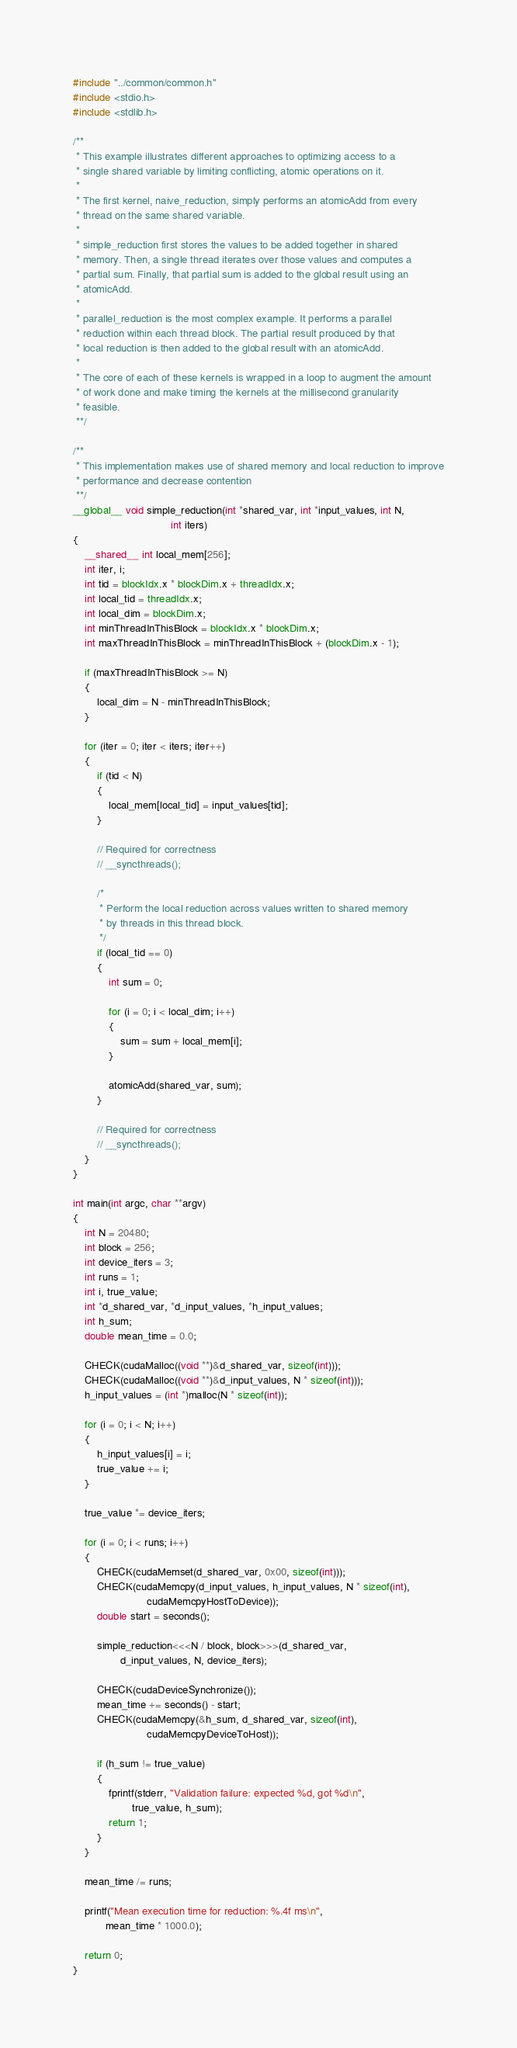<code> <loc_0><loc_0><loc_500><loc_500><_Cuda_>#include "../common/common.h"
#include <stdio.h>
#include <stdlib.h>

/**
 * This example illustrates different approaches to optimizing access to a
 * single shared variable by limiting conflicting, atomic operations on it.
 *
 * The first kernel, naive_reduction, simply performs an atomicAdd from every
 * thread on the same shared variable.
 *
 * simple_reduction first stores the values to be added together in shared
 * memory. Then, a single thread iterates over those values and computes a
 * partial sum. Finally, that partial sum is added to the global result using an
 * atomicAdd.
 *
 * parallel_reduction is the most complex example. It performs a parallel
 * reduction within each thread block. The partial result produced by that
 * local reduction is then added to the global result with an atomicAdd.
 *
 * The core of each of these kernels is wrapped in a loop to augment the amount
 * of work done and make timing the kernels at the millisecond granularity
 * feasible.
 **/

/**
 * This implementation makes use of shared memory and local reduction to improve
 * performance and decrease contention
 **/
__global__ void simple_reduction(int *shared_var, int *input_values, int N,
                                 int iters)
{
    __shared__ int local_mem[256];
    int iter, i;
    int tid = blockIdx.x * blockDim.x + threadIdx.x;
    int local_tid = threadIdx.x;
    int local_dim = blockDim.x;
    int minThreadInThisBlock = blockIdx.x * blockDim.x;
    int maxThreadInThisBlock = minThreadInThisBlock + (blockDim.x - 1);

    if (maxThreadInThisBlock >= N)
    {
        local_dim = N - minThreadInThisBlock;
    }

    for (iter = 0; iter < iters; iter++)
    {
        if (tid < N)
        {
            local_mem[local_tid] = input_values[tid];
        }

        // Required for correctness
        // __syncthreads();

        /*
         * Perform the local reduction across values written to shared memory
         * by threads in this thread block.
         */
        if (local_tid == 0)
        {
            int sum = 0;

            for (i = 0; i < local_dim; i++)
            {
                sum = sum + local_mem[i];
            }

            atomicAdd(shared_var, sum);
        }

        // Required for correctness
        // __syncthreads();
    }
}

int main(int argc, char **argv)
{
    int N = 20480;
    int block = 256;
    int device_iters = 3;
    int runs = 1;
    int i, true_value;
    int *d_shared_var, *d_input_values, *h_input_values;
    int h_sum;
    double mean_time = 0.0;

    CHECK(cudaMalloc((void **)&d_shared_var, sizeof(int)));
    CHECK(cudaMalloc((void **)&d_input_values, N * sizeof(int)));
    h_input_values = (int *)malloc(N * sizeof(int));

    for (i = 0; i < N; i++)
    {
        h_input_values[i] = i;
        true_value += i;
    }

    true_value *= device_iters;

    for (i = 0; i < runs; i++)
    {
        CHECK(cudaMemset(d_shared_var, 0x00, sizeof(int)));
        CHECK(cudaMemcpy(d_input_values, h_input_values, N * sizeof(int),
                         cudaMemcpyHostToDevice));
        double start = seconds();

        simple_reduction<<<N / block, block>>>(d_shared_var,
                d_input_values, N, device_iters);

        CHECK(cudaDeviceSynchronize());
        mean_time += seconds() - start;
        CHECK(cudaMemcpy(&h_sum, d_shared_var, sizeof(int),
                         cudaMemcpyDeviceToHost));

        if (h_sum != true_value)
        {
            fprintf(stderr, "Validation failure: expected %d, got %d\n",
                    true_value, h_sum);
            return 1;
        }
    }

    mean_time /= runs;

    printf("Mean execution time for reduction: %.4f ms\n",
           mean_time * 1000.0);

    return 0;
}
</code> 